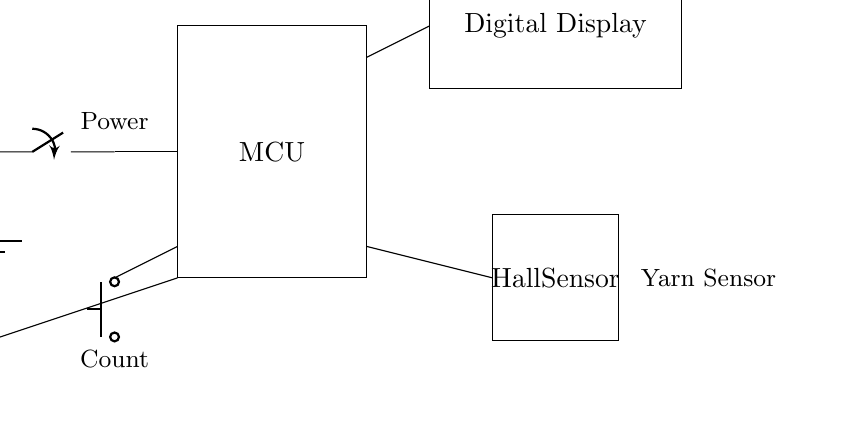What is the voltage of the battery? The circuit diagram shows a battery labeled with a voltage of 3 volts. This is indicated next to the battery symbol, confirming that the source of power for the circuit is 3 volts.
Answer: 3 volts What type of sensor is used in this circuit? The circuit includes a rectangle labeled "Hall Sensor," indicating that a Hall effect sensor is employed in this device for detecting the presence of yarn. This recognition helps track the rows and stitches effectively.
Answer: Hall effect sensor Where does the push button connect? The push button connects to the microcontroller (MCU) as shown by the lines that lead from the push button to the MCU. The push button activates or increments the counter which is managed by the MCU.
Answer: To the microcontroller How many main components are in the circuit? The circuit contains five main components: the battery, switch, microcontroller, push button, and Hall sensor, as well as a digital display for output. Counting these elements shows a total of five distinct parts.
Answer: Five What is the purpose of the digital display? The digital display's purpose is to show the count of rows and stitches, specifically indicated in the circuit diagram where it is labeled "Digital Display." It connects to the microcontroller to relay the counting information.
Answer: To show the count What component is labeled as "Count" in the circuit? The "Count" label refers to the push button in the circuit. This button is used to increment the count, which represents the number of rows or stitches tracked.
Answer: The push button How is the MCU powered in this circuit? The MCU is powered directly by the battery as indicated by the connection line between the battery and MCU. The battery serves as the power source, ensuring the microcontroller has the necessary voltage to operate.
Answer: By the battery 